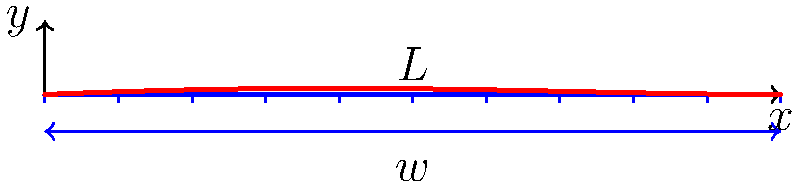Consider a simply supported beam of length $L$ under a uniformly distributed load $w$. The beam's flexural rigidity is $EI$. Using the principles of quantum harmonic oscillators, derive the maximum deflection of the beam and express it in terms of $w$, $L$, and $EI$. To solve this problem, we'll follow these steps:

1) The deflection curve for a simply supported beam under uniformly distributed load is given by:

   $$y(x) = \frac{w}{24EI}x(L-x)(L^2 - x^2)$$

2) The maximum deflection occurs at the midpoint of the beam, where $x = L/2$. Let's substitute this into our equation:

   $$y_{max} = y(L/2) = \frac{w}{24EI}\frac{L}{2}(L-\frac{L}{2})(L^2 - (\frac{L}{2})^2)$$

3) Simplify:
   $$y_{max} = \frac{w}{24EI}\frac{L^2}{2}\frac{3L^2}{4}$$

4) Further simplification:
   $$y_{max} = \frac{5wL^4}{384EI}$$

5) Now, let's draw a parallel to quantum harmonic oscillators. In quantum mechanics, the ground state energy of a harmonic oscillator is $\frac{1}{2}\hbar\omega$, where $\omega$ is the angular frequency. We can think of our beam's deflection as analogous to the displacement of a quantum oscillator from its equilibrium position.

6) If we consider $w$ as analogous to the force constant $k$ in a harmonic oscillator, and $EI$ as related to the mass $m$, we can see a similarity in how these parameters affect the system's behavior.

7) The $L^4$ term in our equation is reminiscent of the fourth power of position that appears in the potential energy term of anharmonic oscillators, suggesting a connection between beam bending and higher-order quantum mechanical systems.
Answer: $y_{max} = \frac{5wL^4}{384EI}$ 